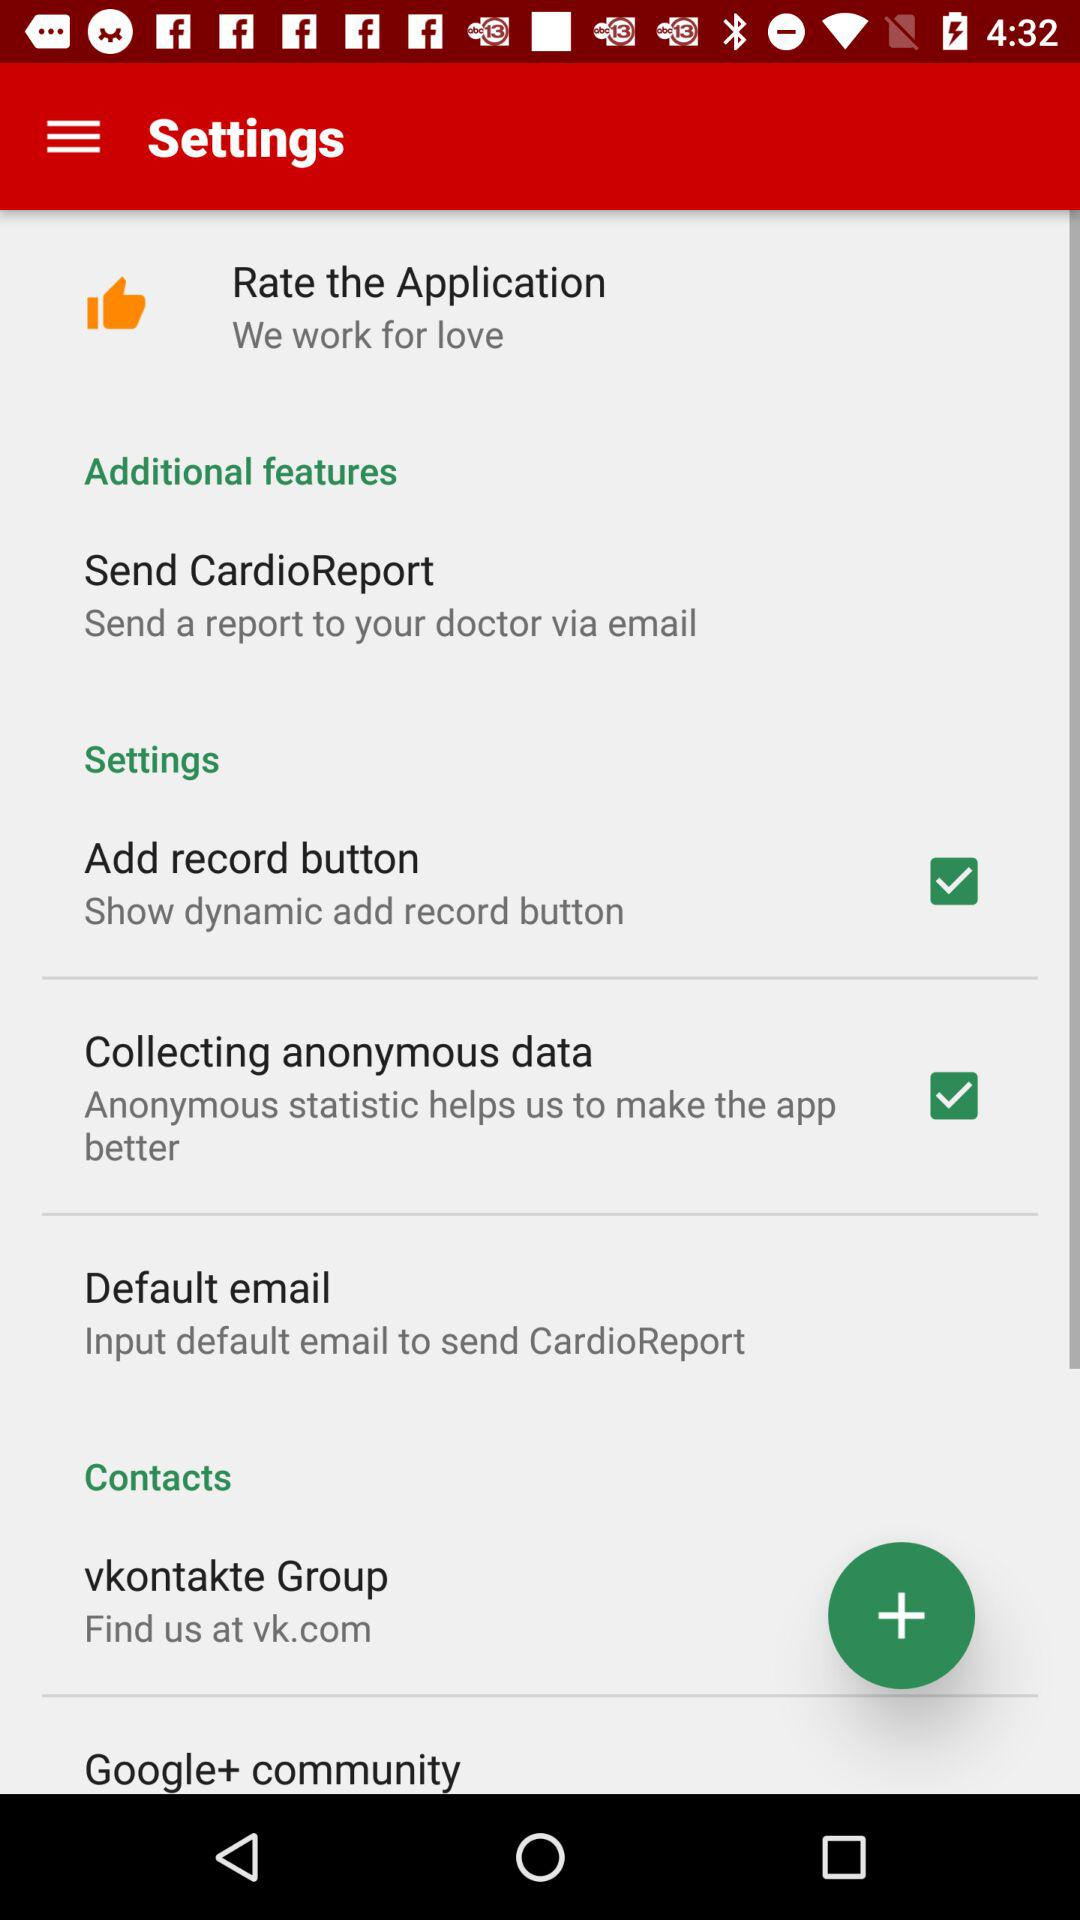What is the status of "Collecting anonymous data"?
Answer the question using a single word or phrase. The status is "on" 